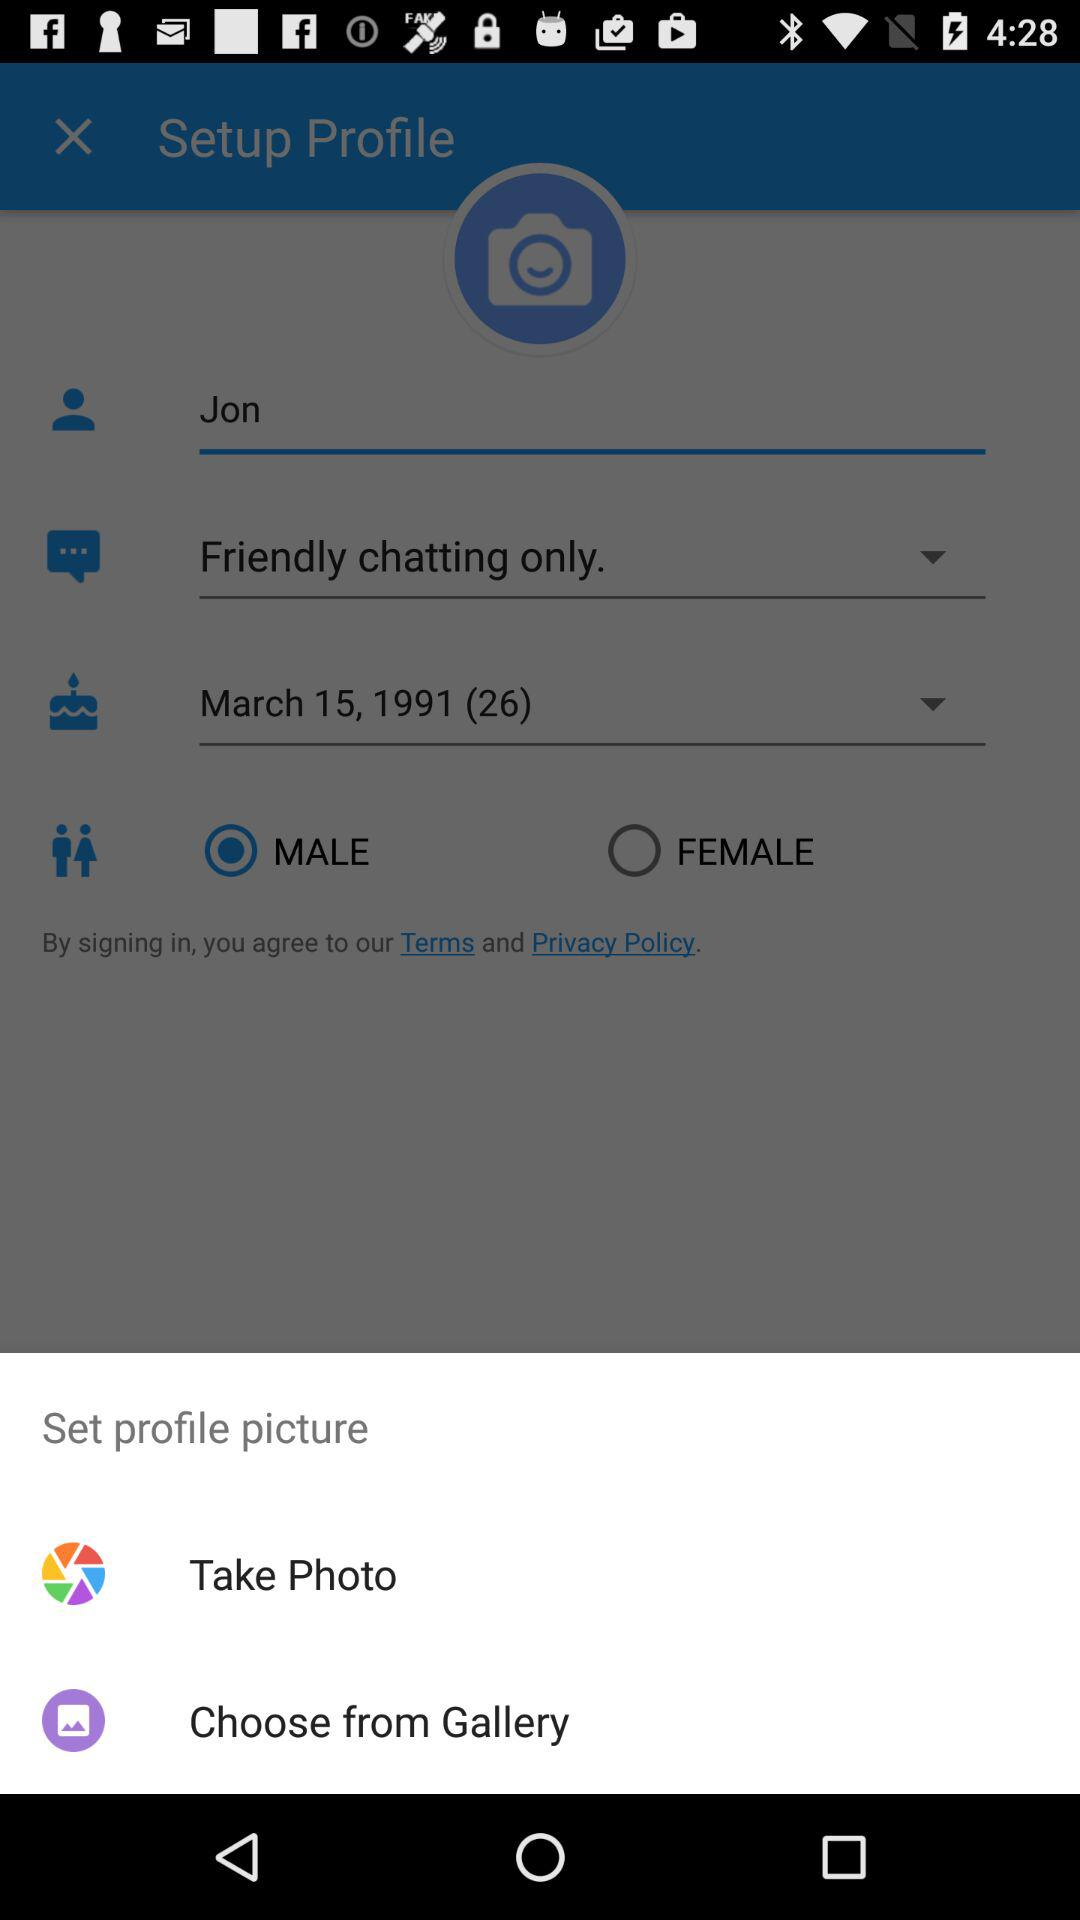What is the birthday date? The birthday date is March 15, 1991. 